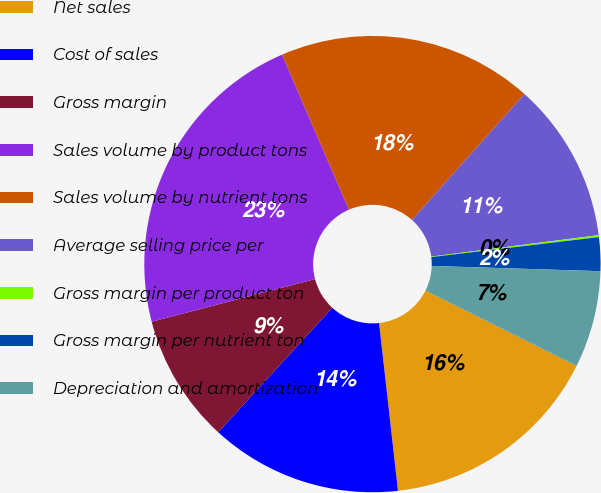<chart> <loc_0><loc_0><loc_500><loc_500><pie_chart><fcel>Net sales<fcel>Cost of sales<fcel>Gross margin<fcel>Sales volume by product tons<fcel>Sales volume by nutrient tons<fcel>Average selling price per<fcel>Gross margin per product ton<fcel>Gross margin per nutrient ton<fcel>Depreciation and amortization<nl><fcel>15.85%<fcel>13.6%<fcel>9.12%<fcel>22.58%<fcel>18.09%<fcel>11.36%<fcel>0.14%<fcel>2.38%<fcel>6.87%<nl></chart> 